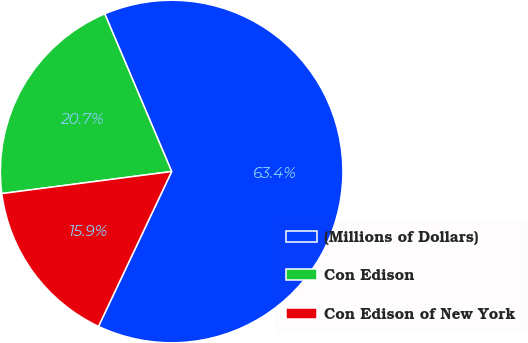Convert chart. <chart><loc_0><loc_0><loc_500><loc_500><pie_chart><fcel>(Millions of Dollars)<fcel>Con Edison<fcel>Con Edison of New York<nl><fcel>63.42%<fcel>20.67%<fcel>15.92%<nl></chart> 